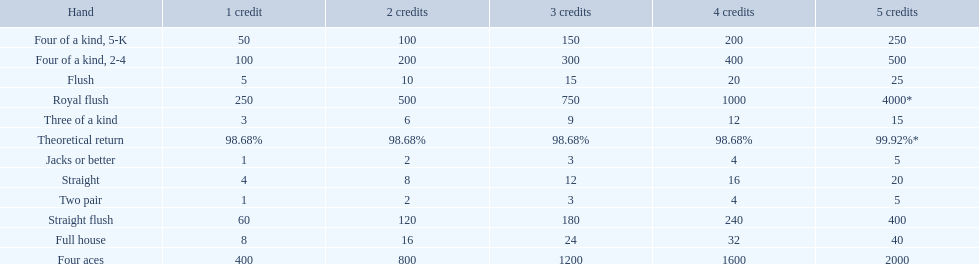What are the top 5 best types of hand for winning? Royal flush, Straight flush, Four aces, Four of a kind, 2-4, Four of a kind, 5-K. Between those 5, which of those hands are four of a kind? Four of a kind, 2-4, Four of a kind, 5-K. Of those 2 hands, which is the best kind of four of a kind for winning? Four of a kind, 2-4. 